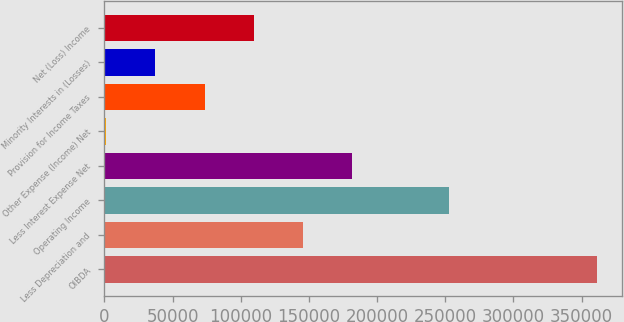Convert chart. <chart><loc_0><loc_0><loc_500><loc_500><bar_chart><fcel>OIBDA<fcel>Less Depreciation and<fcel>Operating Income<fcel>Less Interest Expense Net<fcel>Other Expense (Income) Net<fcel>Provision for Income Taxes<fcel>Minority Interests in (Losses)<fcel>Net (Loss) Income<nl><fcel>361578<fcel>145492<fcel>252586<fcel>181506<fcel>1435<fcel>73463.6<fcel>37449.3<fcel>109478<nl></chart> 